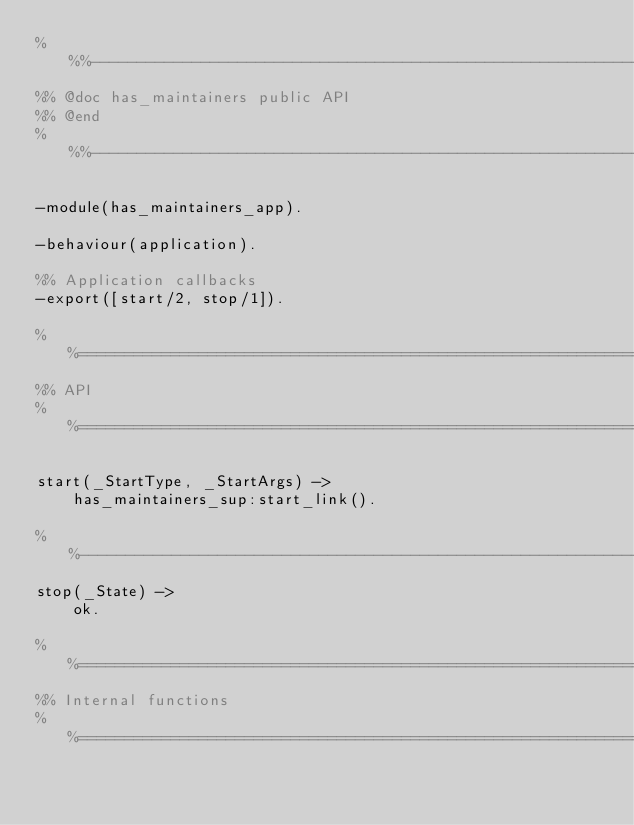Convert code to text. <code><loc_0><loc_0><loc_500><loc_500><_Erlang_>%%%-------------------------------------------------------------------
%% @doc has_maintainers public API
%% @end
%%%-------------------------------------------------------------------

-module(has_maintainers_app).

-behaviour(application).

%% Application callbacks
-export([start/2, stop/1]).

%%====================================================================
%% API
%%====================================================================

start(_StartType, _StartArgs) ->
    has_maintainers_sup:start_link().

%%--------------------------------------------------------------------
stop(_State) ->
    ok.

%%====================================================================
%% Internal functions
%%====================================================================
</code> 